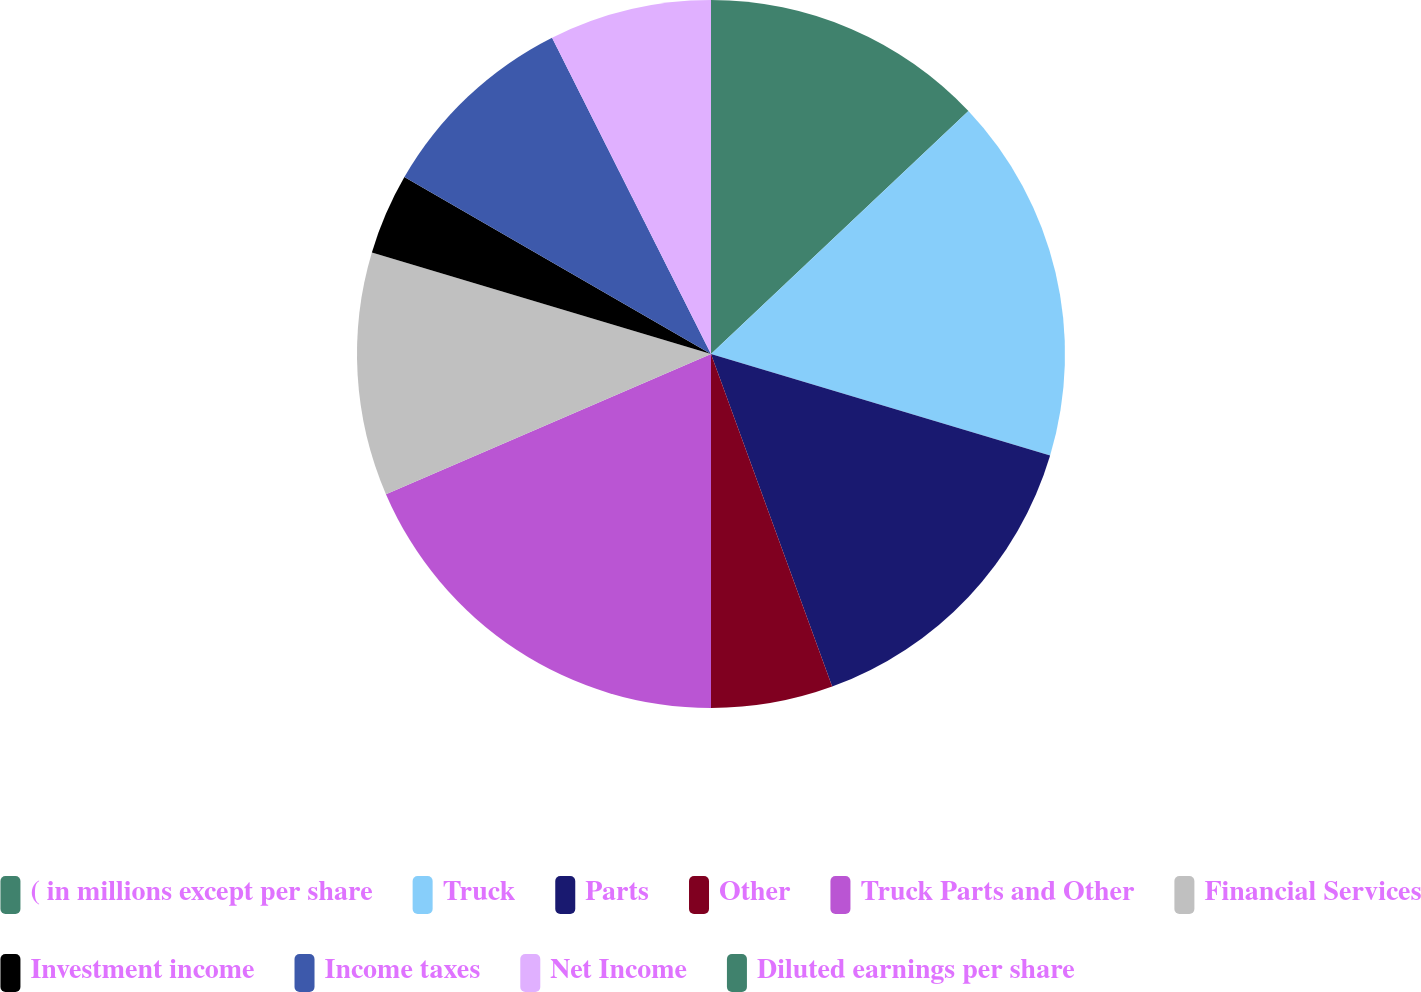Convert chart. <chart><loc_0><loc_0><loc_500><loc_500><pie_chart><fcel>( in millions except per share<fcel>Truck<fcel>Parts<fcel>Other<fcel>Truck Parts and Other<fcel>Financial Services<fcel>Investment income<fcel>Income taxes<fcel>Net Income<fcel>Diluted earnings per share<nl><fcel>12.96%<fcel>16.67%<fcel>14.81%<fcel>5.56%<fcel>18.52%<fcel>11.11%<fcel>3.7%<fcel>9.26%<fcel>7.41%<fcel>0.0%<nl></chart> 